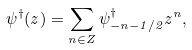Convert formula to latex. <formula><loc_0><loc_0><loc_500><loc_500>\psi ^ { \dagger } ( z ) = \sum _ { n \in { Z } } \psi ^ { \dagger } _ { - n - 1 / 2 } z ^ { n } ,</formula> 